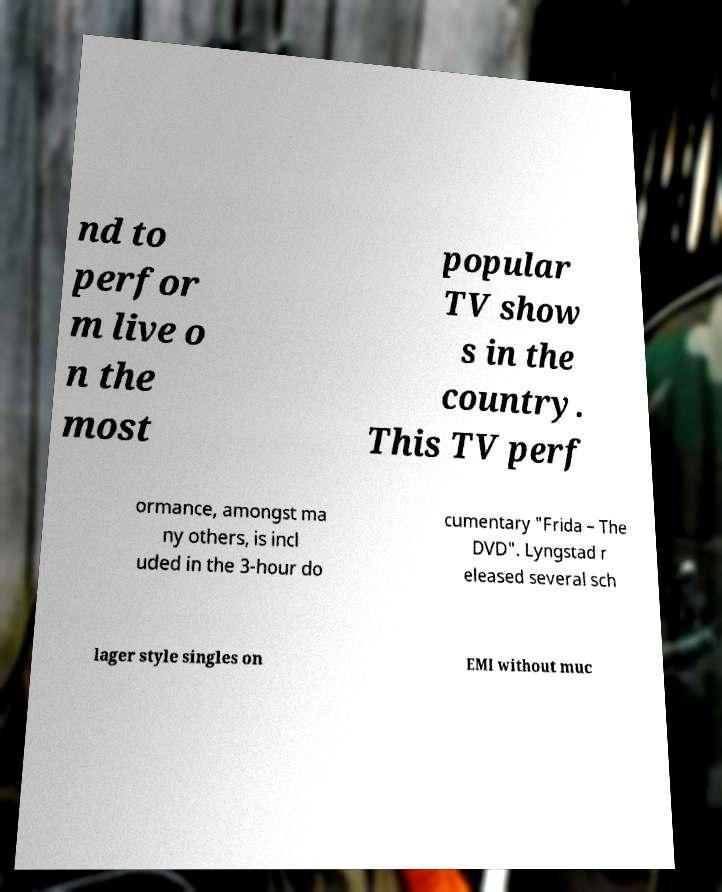Can you accurately transcribe the text from the provided image for me? nd to perfor m live o n the most popular TV show s in the country. This TV perf ormance, amongst ma ny others, is incl uded in the 3-hour do cumentary "Frida – The DVD". Lyngstad r eleased several sch lager style singles on EMI without muc 